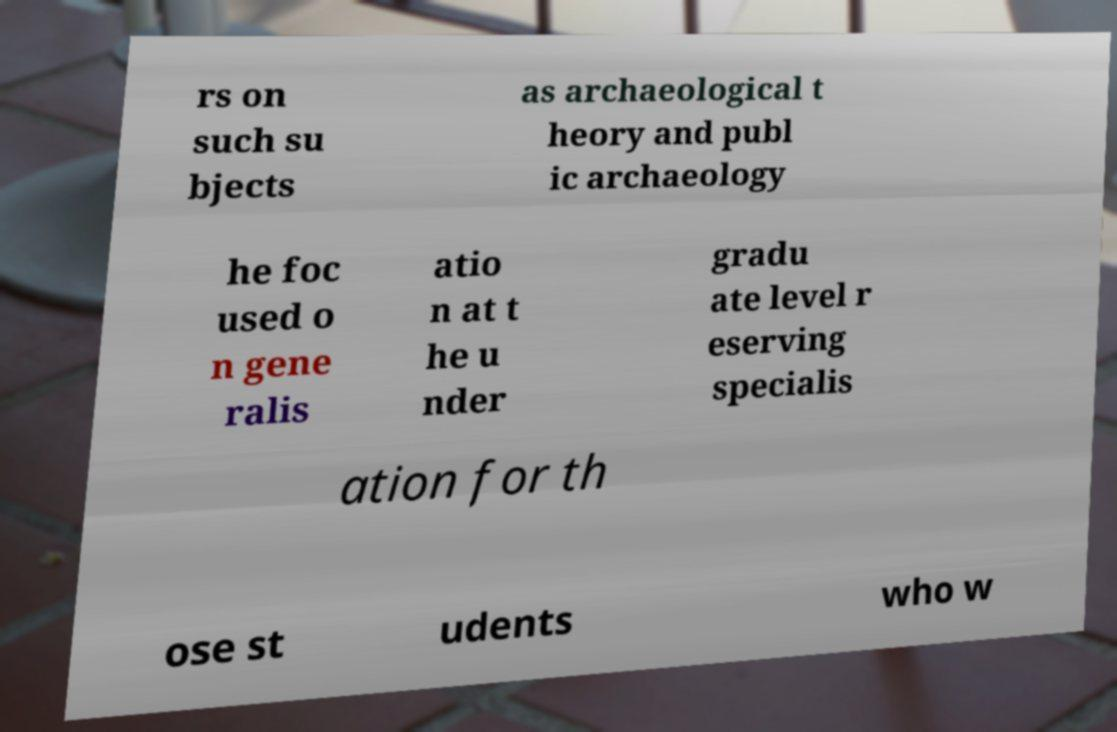Could you assist in decoding the text presented in this image and type it out clearly? rs on such su bjects as archaeological t heory and publ ic archaeology he foc used o n gene ralis atio n at t he u nder gradu ate level r eserving specialis ation for th ose st udents who w 